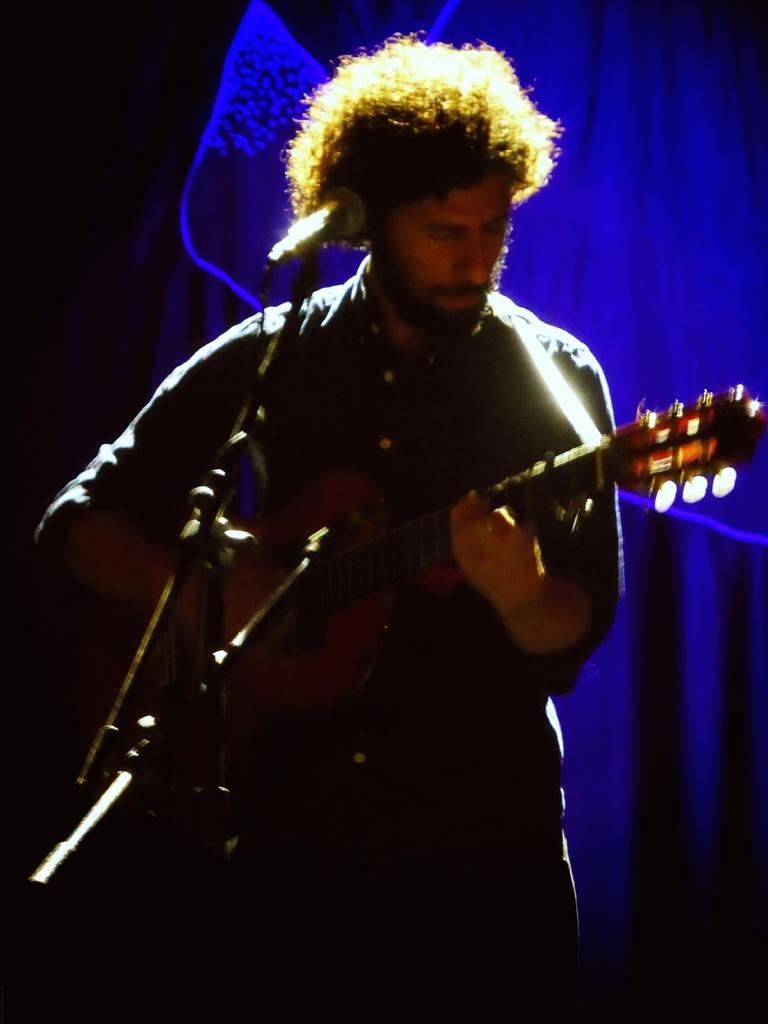What is the man in the image doing? The man is standing in the image and holding a guitar. What object is present in the image that is typically used for amplifying sound? There is a microphone with a microphone stand in the image. What can be seen in the background of the image? There is a cloth visible in the background of the image. How many toes can be seen on the man's foot in the image? There is no visible foot or toes in the image, as the man is standing and holding a guitar. 